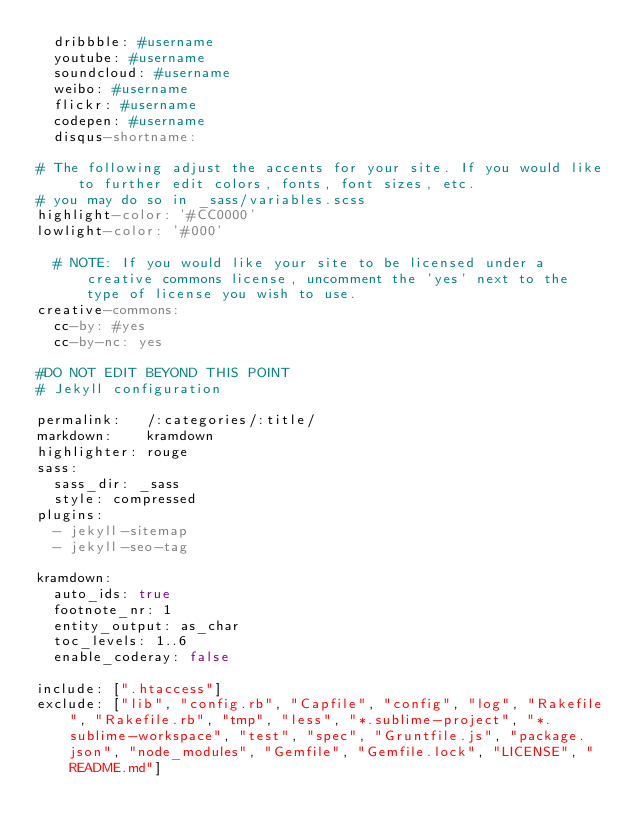Convert code to text. <code><loc_0><loc_0><loc_500><loc_500><_YAML_>  dribbble: #username
  youtube: #username
  soundcloud: #username
  weibo: #username
  flickr: #username
  codepen: #username
  disqus-shortname:

# The following adjust the accents for your site. If you would like to further edit colors, fonts, font sizes, etc.
# you may do so in _sass/variables.scss
highlight-color: '#CC0000'
lowlight-color: '#000'

  # NOTE: If you would like your site to be licensed under a creative commons license, uncomment the 'yes' next to the type of license you wish to use.
creative-commons:
  cc-by: #yes
  cc-by-nc: yes

#DO NOT EDIT BEYOND THIS POINT
# Jekyll configuration

permalink:   /:categories/:title/
markdown:    kramdown
highlighter: rouge
sass:
  sass_dir: _sass
  style: compressed
plugins:
  - jekyll-sitemap
  - jekyll-seo-tag

kramdown:
  auto_ids: true
  footnote_nr: 1
  entity_output: as_char
  toc_levels: 1..6
  enable_coderay: false

include: [".htaccess"]
exclude: ["lib", "config.rb", "Capfile", "config", "log", "Rakefile", "Rakefile.rb", "tmp", "less", "*.sublime-project", "*.sublime-workspace", "test", "spec", "Gruntfile.js", "package.json", "node_modules", "Gemfile", "Gemfile.lock", "LICENSE", "README.md"]
</code> 